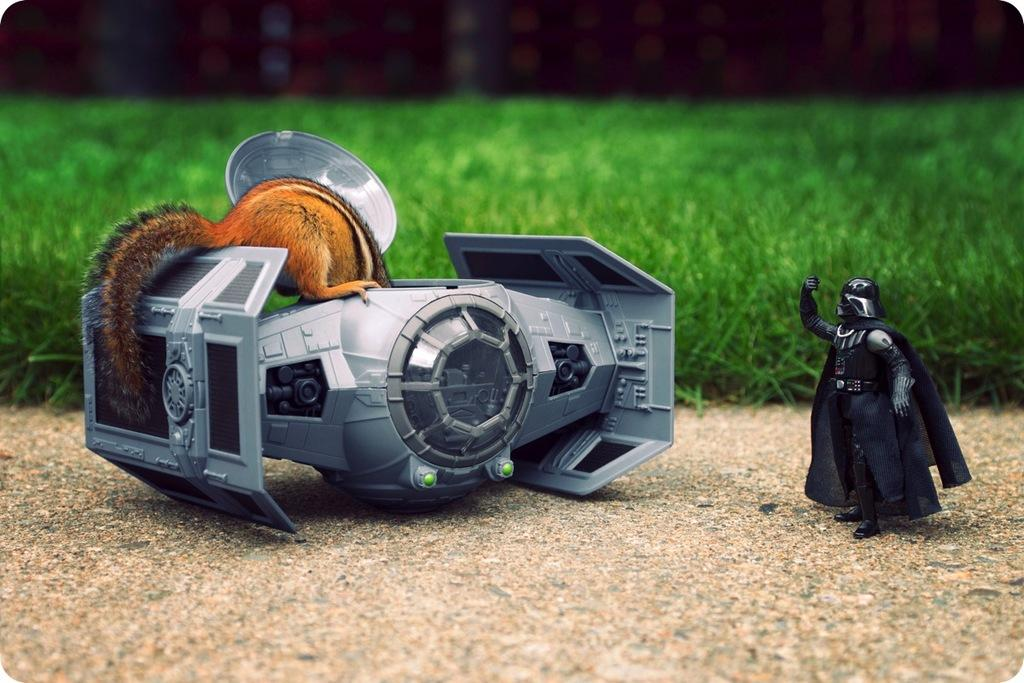What types of toys are present in the image? There is a toy of a man, a toy of a robot, and a toy of a squirrel in the image. What is the background of the image? There is green grass visible in the background of the image. How would you describe the lighting in the image? The top part of the image appears to be dark. What type of pen is being used to draw the robot in the image? There is no pen or drawing activity present in the image; it features toys of a man, a robot, and a squirrel. 